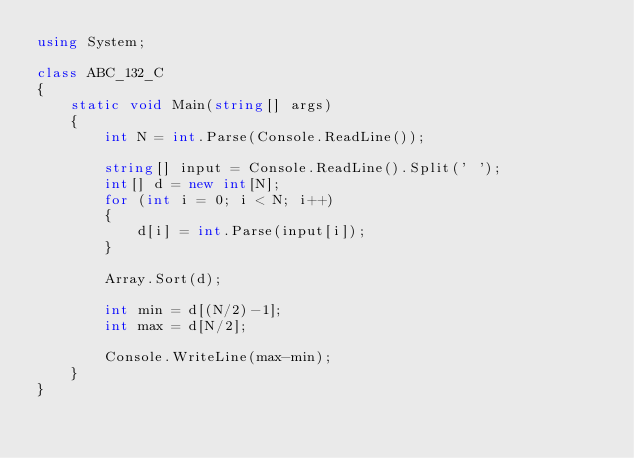Convert code to text. <code><loc_0><loc_0><loc_500><loc_500><_C#_>using System;

class ABC_132_C
{
    static void Main(string[] args)
    {
        int N = int.Parse(Console.ReadLine());

        string[] input = Console.ReadLine().Split(' ');
        int[] d = new int[N];
        for (int i = 0; i < N; i++)
        {
            d[i] = int.Parse(input[i]);
        }

        Array.Sort(d);

        int min = d[(N/2)-1];
        int max = d[N/2];

        Console.WriteLine(max-min);
    }
}</code> 